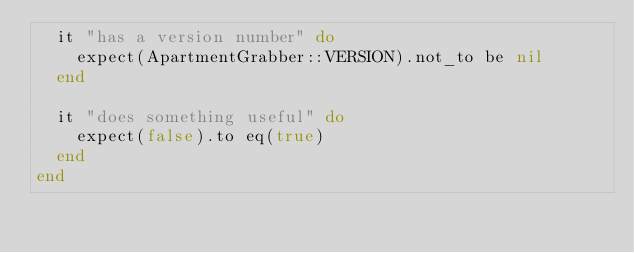Convert code to text. <code><loc_0><loc_0><loc_500><loc_500><_Ruby_>  it "has a version number" do
    expect(ApartmentGrabber::VERSION).not_to be nil
  end

  it "does something useful" do
    expect(false).to eq(true)
  end
end
</code> 